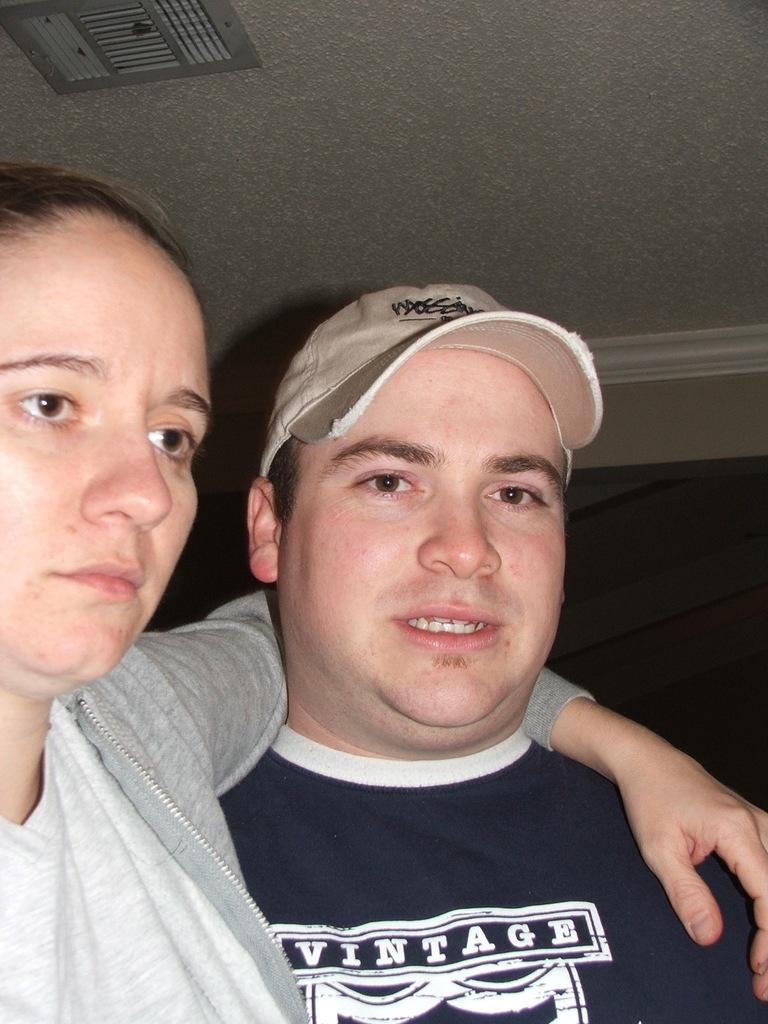<image>
Render a clear and concise summary of the photo. A man with a cap is wearing a vintage shirt. 